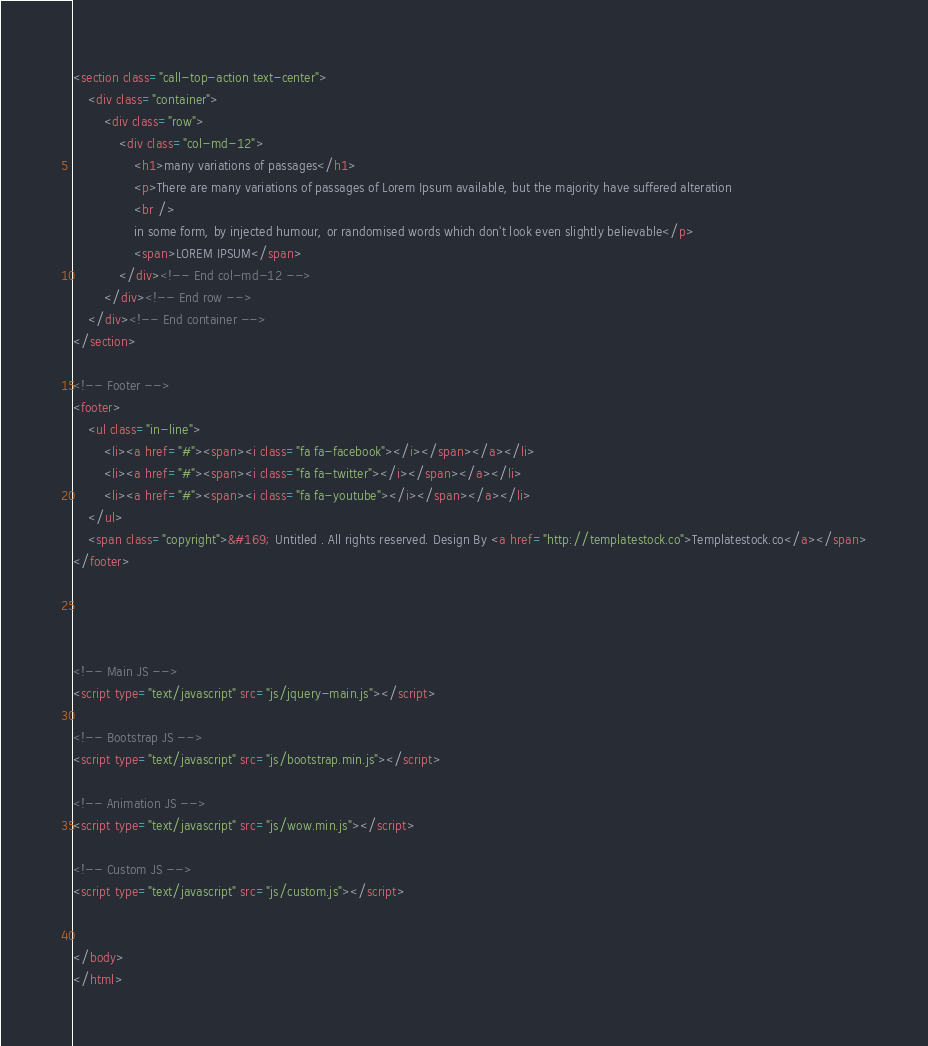Convert code to text. <code><loc_0><loc_0><loc_500><loc_500><_HTML_><section class="call-top-action text-center">
	<div class="container">
		<div class="row">
			<div class="col-md-12">
				<h1>many variations of passages</h1>
				<p>There are many variations of passages of Lorem Ipsum available, but the majority have suffered alteration 
				<br />
				in some form, by injected humour, or randomised words which don't look even slightly believable</p>
				<span>LOREM IPSUM</span>
			</div><!-- End col-md-12 -->
		</div><!-- End row -->
	</div><!-- End container -->
</section>

<!-- Footer -->
<footer>
	<ul class="in-line">
		<li><a href="#"><span><i class="fa fa-facebook"></i></span></a></li>
		<li><a href="#"><span><i class="fa fa-twitter"></i></span></a></li>
		<li><a href="#"><span><i class="fa fa-youtube"></i></span></a></li>
	</ul>
	<span class="copyright">&#169; Untitled . All rights reserved. Design By <a href="http://templatestock.co">Templatestock.co</a></span>
</footer>
	



<!-- Main JS -->
<script type="text/javascript" src="js/jquery-main.js"></script>

<!-- Bootstrap JS -->
<script type="text/javascript" src="js/bootstrap.min.js"></script>

<!-- Animation JS -->
<script type="text/javascript" src="js/wow.min.js"></script>

<!-- Custom JS -->
<script type="text/javascript" src="js/custom.js"></script>


</body>
</html></code> 